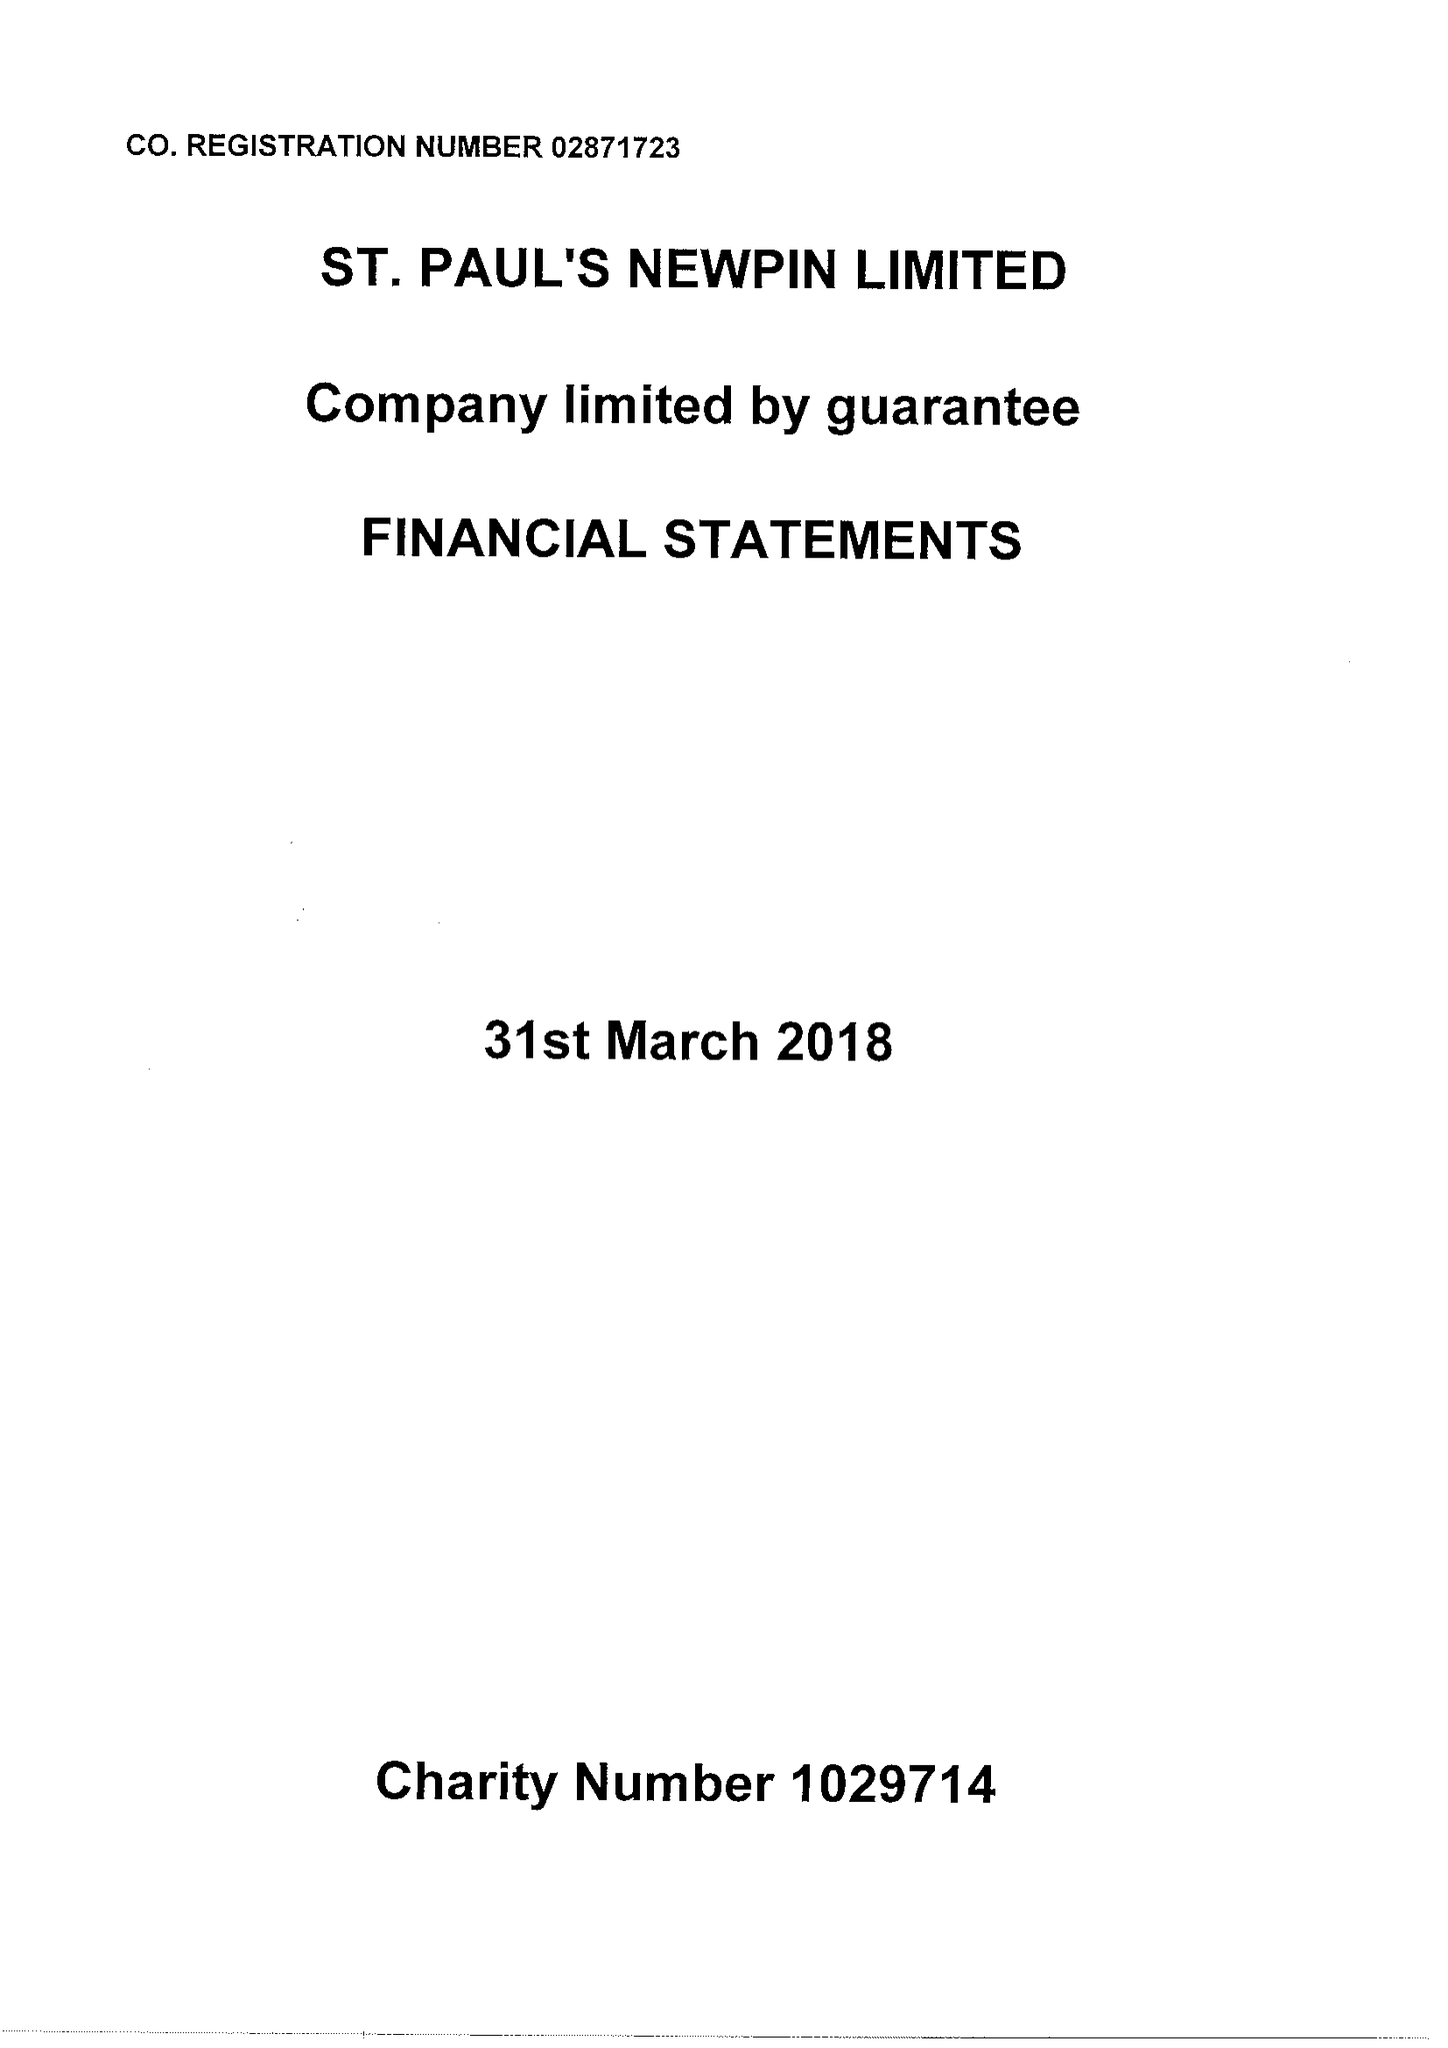What is the value for the charity_name?
Answer the question using a single word or phrase. St Paul's Newpin Ltd. 